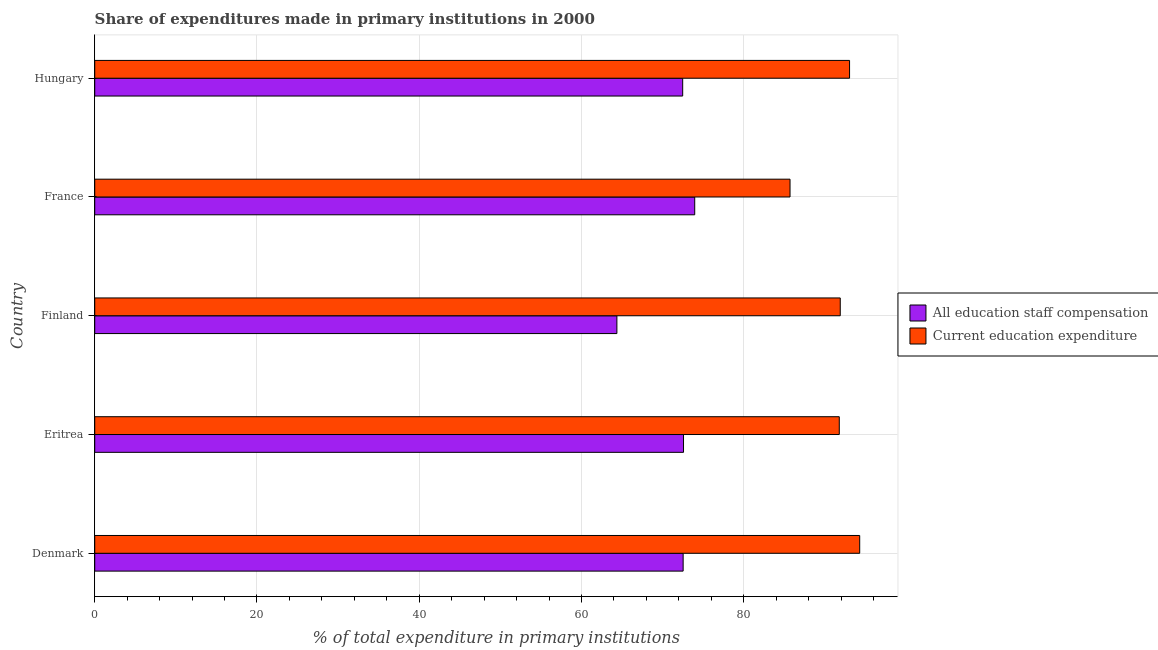How many groups of bars are there?
Give a very brief answer. 5. Are the number of bars on each tick of the Y-axis equal?
Keep it short and to the point. Yes. What is the expenditure in education in Denmark?
Your response must be concise. 94.29. Across all countries, what is the maximum expenditure in education?
Offer a terse response. 94.29. Across all countries, what is the minimum expenditure in education?
Offer a terse response. 85.7. In which country was the expenditure in education maximum?
Your answer should be very brief. Denmark. In which country was the expenditure in education minimum?
Give a very brief answer. France. What is the total expenditure in education in the graph?
Ensure brevity in your answer.  456.69. What is the difference between the expenditure in staff compensation in Denmark and that in France?
Give a very brief answer. -1.43. What is the difference between the expenditure in staff compensation in Hungary and the expenditure in education in Finland?
Keep it short and to the point. -19.42. What is the average expenditure in staff compensation per country?
Give a very brief answer. 71.18. What is the difference between the expenditure in education and expenditure in staff compensation in Denmark?
Provide a short and direct response. 21.76. In how many countries, is the expenditure in education greater than 80 %?
Ensure brevity in your answer.  5. What is the ratio of the expenditure in education in Denmark to that in France?
Ensure brevity in your answer.  1.1. What is the difference between the highest and the second highest expenditure in education?
Offer a terse response. 1.25. What is the difference between the highest and the lowest expenditure in education?
Give a very brief answer. 8.59. In how many countries, is the expenditure in education greater than the average expenditure in education taken over all countries?
Ensure brevity in your answer.  4. Is the sum of the expenditure in staff compensation in Denmark and Eritrea greater than the maximum expenditure in education across all countries?
Your answer should be very brief. Yes. What does the 1st bar from the top in Finland represents?
Your answer should be compact. Current education expenditure. What does the 2nd bar from the bottom in Finland represents?
Your answer should be compact. Current education expenditure. What is the difference between two consecutive major ticks on the X-axis?
Provide a succinct answer. 20. Does the graph contain grids?
Provide a short and direct response. Yes. Where does the legend appear in the graph?
Keep it short and to the point. Center right. How many legend labels are there?
Make the answer very short. 2. What is the title of the graph?
Your answer should be very brief. Share of expenditures made in primary institutions in 2000. Does "Canada" appear as one of the legend labels in the graph?
Keep it short and to the point. No. What is the label or title of the X-axis?
Your answer should be compact. % of total expenditure in primary institutions. What is the label or title of the Y-axis?
Provide a succinct answer. Country. What is the % of total expenditure in primary institutions in All education staff compensation in Denmark?
Give a very brief answer. 72.53. What is the % of total expenditure in primary institutions of Current education expenditure in Denmark?
Keep it short and to the point. 94.29. What is the % of total expenditure in primary institutions in All education staff compensation in Eritrea?
Your response must be concise. 72.57. What is the % of total expenditure in primary institutions of Current education expenditure in Eritrea?
Give a very brief answer. 91.77. What is the % of total expenditure in primary institutions of All education staff compensation in Finland?
Your response must be concise. 64.36. What is the % of total expenditure in primary institutions in Current education expenditure in Finland?
Your answer should be compact. 91.89. What is the % of total expenditure in primary institutions in All education staff compensation in France?
Your answer should be very brief. 73.95. What is the % of total expenditure in primary institutions in Current education expenditure in France?
Make the answer very short. 85.7. What is the % of total expenditure in primary institutions of All education staff compensation in Hungary?
Provide a short and direct response. 72.47. What is the % of total expenditure in primary institutions of Current education expenditure in Hungary?
Offer a terse response. 93.04. Across all countries, what is the maximum % of total expenditure in primary institutions in All education staff compensation?
Provide a succinct answer. 73.95. Across all countries, what is the maximum % of total expenditure in primary institutions in Current education expenditure?
Offer a very short reply. 94.29. Across all countries, what is the minimum % of total expenditure in primary institutions of All education staff compensation?
Provide a short and direct response. 64.36. Across all countries, what is the minimum % of total expenditure in primary institutions of Current education expenditure?
Ensure brevity in your answer.  85.7. What is the total % of total expenditure in primary institutions in All education staff compensation in the graph?
Offer a terse response. 355.88. What is the total % of total expenditure in primary institutions of Current education expenditure in the graph?
Make the answer very short. 456.69. What is the difference between the % of total expenditure in primary institutions of All education staff compensation in Denmark and that in Eritrea?
Provide a short and direct response. -0.05. What is the difference between the % of total expenditure in primary institutions in Current education expenditure in Denmark and that in Eritrea?
Provide a succinct answer. 2.52. What is the difference between the % of total expenditure in primary institutions in All education staff compensation in Denmark and that in Finland?
Your answer should be compact. 8.17. What is the difference between the % of total expenditure in primary institutions in Current education expenditure in Denmark and that in Finland?
Your answer should be very brief. 2.4. What is the difference between the % of total expenditure in primary institutions in All education staff compensation in Denmark and that in France?
Your answer should be compact. -1.43. What is the difference between the % of total expenditure in primary institutions in Current education expenditure in Denmark and that in France?
Offer a very short reply. 8.59. What is the difference between the % of total expenditure in primary institutions of All education staff compensation in Denmark and that in Hungary?
Ensure brevity in your answer.  0.06. What is the difference between the % of total expenditure in primary institutions in Current education expenditure in Denmark and that in Hungary?
Your response must be concise. 1.25. What is the difference between the % of total expenditure in primary institutions in All education staff compensation in Eritrea and that in Finland?
Offer a very short reply. 8.21. What is the difference between the % of total expenditure in primary institutions in Current education expenditure in Eritrea and that in Finland?
Make the answer very short. -0.12. What is the difference between the % of total expenditure in primary institutions of All education staff compensation in Eritrea and that in France?
Provide a short and direct response. -1.38. What is the difference between the % of total expenditure in primary institutions in Current education expenditure in Eritrea and that in France?
Offer a terse response. 6.07. What is the difference between the % of total expenditure in primary institutions of All education staff compensation in Eritrea and that in Hungary?
Your response must be concise. 0.1. What is the difference between the % of total expenditure in primary institutions in Current education expenditure in Eritrea and that in Hungary?
Offer a terse response. -1.27. What is the difference between the % of total expenditure in primary institutions in All education staff compensation in Finland and that in France?
Your answer should be very brief. -9.59. What is the difference between the % of total expenditure in primary institutions in Current education expenditure in Finland and that in France?
Make the answer very short. 6.19. What is the difference between the % of total expenditure in primary institutions in All education staff compensation in Finland and that in Hungary?
Keep it short and to the point. -8.11. What is the difference between the % of total expenditure in primary institutions in Current education expenditure in Finland and that in Hungary?
Your answer should be compact. -1.15. What is the difference between the % of total expenditure in primary institutions in All education staff compensation in France and that in Hungary?
Offer a terse response. 1.48. What is the difference between the % of total expenditure in primary institutions in Current education expenditure in France and that in Hungary?
Your response must be concise. -7.34. What is the difference between the % of total expenditure in primary institutions in All education staff compensation in Denmark and the % of total expenditure in primary institutions in Current education expenditure in Eritrea?
Give a very brief answer. -19.25. What is the difference between the % of total expenditure in primary institutions in All education staff compensation in Denmark and the % of total expenditure in primary institutions in Current education expenditure in Finland?
Offer a very short reply. -19.37. What is the difference between the % of total expenditure in primary institutions of All education staff compensation in Denmark and the % of total expenditure in primary institutions of Current education expenditure in France?
Offer a very short reply. -13.17. What is the difference between the % of total expenditure in primary institutions of All education staff compensation in Denmark and the % of total expenditure in primary institutions of Current education expenditure in Hungary?
Your answer should be compact. -20.51. What is the difference between the % of total expenditure in primary institutions in All education staff compensation in Eritrea and the % of total expenditure in primary institutions in Current education expenditure in Finland?
Your answer should be compact. -19.32. What is the difference between the % of total expenditure in primary institutions in All education staff compensation in Eritrea and the % of total expenditure in primary institutions in Current education expenditure in France?
Provide a succinct answer. -13.13. What is the difference between the % of total expenditure in primary institutions of All education staff compensation in Eritrea and the % of total expenditure in primary institutions of Current education expenditure in Hungary?
Ensure brevity in your answer.  -20.47. What is the difference between the % of total expenditure in primary institutions of All education staff compensation in Finland and the % of total expenditure in primary institutions of Current education expenditure in France?
Ensure brevity in your answer.  -21.34. What is the difference between the % of total expenditure in primary institutions of All education staff compensation in Finland and the % of total expenditure in primary institutions of Current education expenditure in Hungary?
Provide a short and direct response. -28.68. What is the difference between the % of total expenditure in primary institutions of All education staff compensation in France and the % of total expenditure in primary institutions of Current education expenditure in Hungary?
Provide a short and direct response. -19.09. What is the average % of total expenditure in primary institutions in All education staff compensation per country?
Ensure brevity in your answer.  71.18. What is the average % of total expenditure in primary institutions in Current education expenditure per country?
Offer a terse response. 91.34. What is the difference between the % of total expenditure in primary institutions in All education staff compensation and % of total expenditure in primary institutions in Current education expenditure in Denmark?
Make the answer very short. -21.76. What is the difference between the % of total expenditure in primary institutions of All education staff compensation and % of total expenditure in primary institutions of Current education expenditure in Eritrea?
Provide a short and direct response. -19.2. What is the difference between the % of total expenditure in primary institutions of All education staff compensation and % of total expenditure in primary institutions of Current education expenditure in Finland?
Give a very brief answer. -27.53. What is the difference between the % of total expenditure in primary institutions of All education staff compensation and % of total expenditure in primary institutions of Current education expenditure in France?
Offer a terse response. -11.75. What is the difference between the % of total expenditure in primary institutions of All education staff compensation and % of total expenditure in primary institutions of Current education expenditure in Hungary?
Your response must be concise. -20.57. What is the ratio of the % of total expenditure in primary institutions of All education staff compensation in Denmark to that in Eritrea?
Your answer should be compact. 1. What is the ratio of the % of total expenditure in primary institutions in Current education expenditure in Denmark to that in Eritrea?
Provide a succinct answer. 1.03. What is the ratio of the % of total expenditure in primary institutions in All education staff compensation in Denmark to that in Finland?
Keep it short and to the point. 1.13. What is the ratio of the % of total expenditure in primary institutions in Current education expenditure in Denmark to that in Finland?
Your answer should be very brief. 1.03. What is the ratio of the % of total expenditure in primary institutions in All education staff compensation in Denmark to that in France?
Make the answer very short. 0.98. What is the ratio of the % of total expenditure in primary institutions in Current education expenditure in Denmark to that in France?
Ensure brevity in your answer.  1.1. What is the ratio of the % of total expenditure in primary institutions of Current education expenditure in Denmark to that in Hungary?
Give a very brief answer. 1.01. What is the ratio of the % of total expenditure in primary institutions of All education staff compensation in Eritrea to that in Finland?
Offer a very short reply. 1.13. What is the ratio of the % of total expenditure in primary institutions of Current education expenditure in Eritrea to that in Finland?
Offer a terse response. 1. What is the ratio of the % of total expenditure in primary institutions in All education staff compensation in Eritrea to that in France?
Offer a terse response. 0.98. What is the ratio of the % of total expenditure in primary institutions of Current education expenditure in Eritrea to that in France?
Ensure brevity in your answer.  1.07. What is the ratio of the % of total expenditure in primary institutions of All education staff compensation in Eritrea to that in Hungary?
Offer a terse response. 1. What is the ratio of the % of total expenditure in primary institutions of Current education expenditure in Eritrea to that in Hungary?
Give a very brief answer. 0.99. What is the ratio of the % of total expenditure in primary institutions of All education staff compensation in Finland to that in France?
Your answer should be very brief. 0.87. What is the ratio of the % of total expenditure in primary institutions of Current education expenditure in Finland to that in France?
Offer a very short reply. 1.07. What is the ratio of the % of total expenditure in primary institutions of All education staff compensation in Finland to that in Hungary?
Ensure brevity in your answer.  0.89. What is the ratio of the % of total expenditure in primary institutions of All education staff compensation in France to that in Hungary?
Your response must be concise. 1.02. What is the ratio of the % of total expenditure in primary institutions in Current education expenditure in France to that in Hungary?
Make the answer very short. 0.92. What is the difference between the highest and the second highest % of total expenditure in primary institutions in All education staff compensation?
Give a very brief answer. 1.38. What is the difference between the highest and the second highest % of total expenditure in primary institutions of Current education expenditure?
Keep it short and to the point. 1.25. What is the difference between the highest and the lowest % of total expenditure in primary institutions in All education staff compensation?
Your answer should be compact. 9.59. What is the difference between the highest and the lowest % of total expenditure in primary institutions of Current education expenditure?
Give a very brief answer. 8.59. 